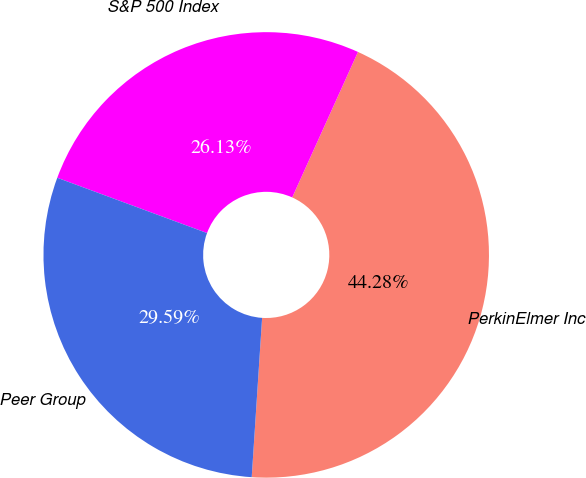Convert chart. <chart><loc_0><loc_0><loc_500><loc_500><pie_chart><fcel>PerkinElmer Inc<fcel>S&P 500 Index<fcel>Peer Group<nl><fcel>44.28%<fcel>26.13%<fcel>29.59%<nl></chart> 